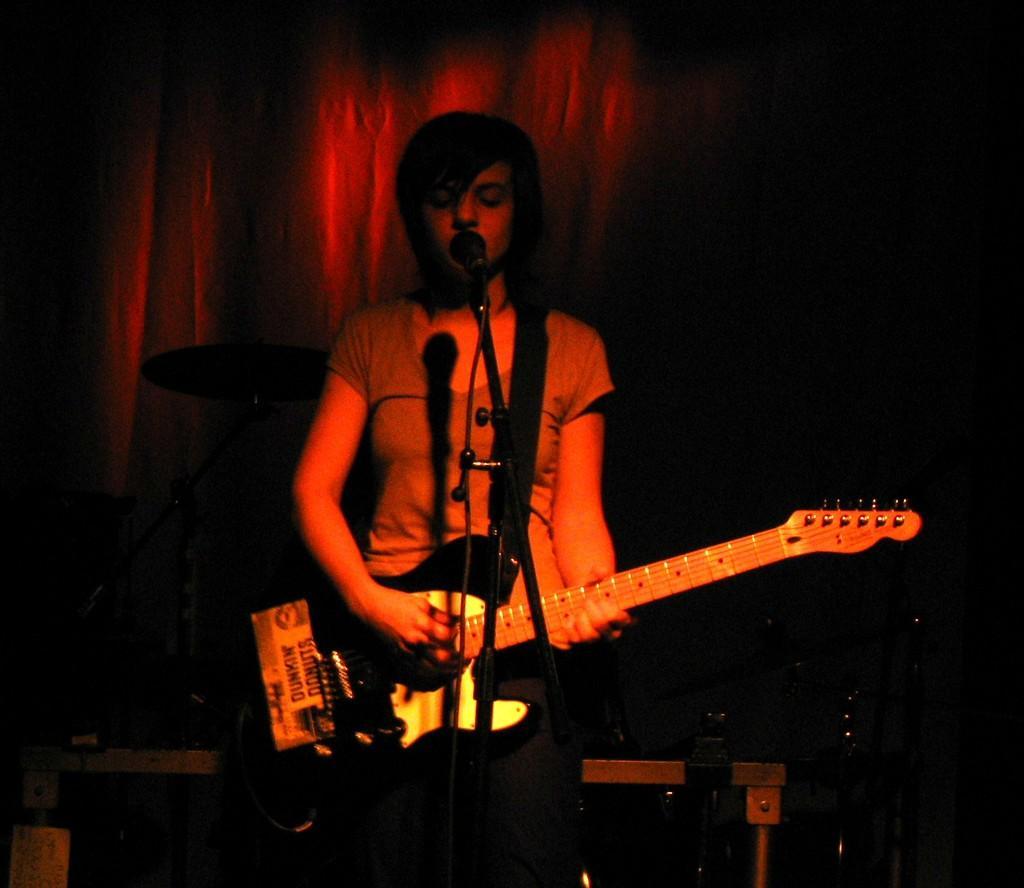Could you give a brief overview of what you see in this image? In the image we can see a person standing, wearing clothes and holding a guitar in hand. This is a microphone and there are objects, and curtains. 